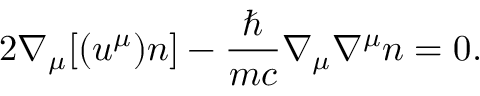<formula> <loc_0><loc_0><loc_500><loc_500>2 \nabla _ { \mu } [ ( u ^ { \mu } ) n ] - \frac { } { m c } \nabla _ { \mu } \nabla ^ { \mu } n = 0 .</formula> 